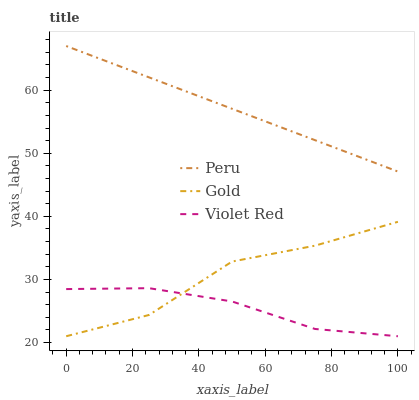Does Violet Red have the minimum area under the curve?
Answer yes or no. Yes. Does Peru have the maximum area under the curve?
Answer yes or no. Yes. Does Gold have the minimum area under the curve?
Answer yes or no. No. Does Gold have the maximum area under the curve?
Answer yes or no. No. Is Peru the smoothest?
Answer yes or no. Yes. Is Gold the roughest?
Answer yes or no. Yes. Is Gold the smoothest?
Answer yes or no. No. Is Peru the roughest?
Answer yes or no. No. Does Violet Red have the lowest value?
Answer yes or no. Yes. Does Peru have the lowest value?
Answer yes or no. No. Does Peru have the highest value?
Answer yes or no. Yes. Does Gold have the highest value?
Answer yes or no. No. Is Gold less than Peru?
Answer yes or no. Yes. Is Peru greater than Gold?
Answer yes or no. Yes. Does Gold intersect Violet Red?
Answer yes or no. Yes. Is Gold less than Violet Red?
Answer yes or no. No. Is Gold greater than Violet Red?
Answer yes or no. No. Does Gold intersect Peru?
Answer yes or no. No. 